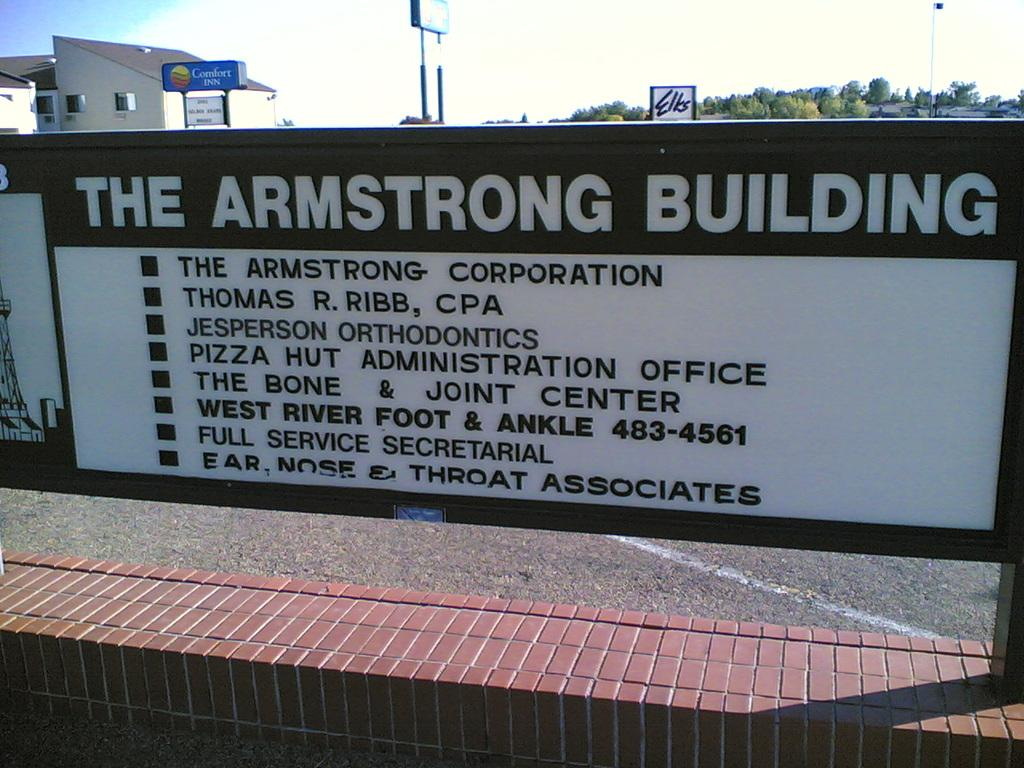<image>
Present a compact description of the photo's key features. A sign that says The Armstrong Building is on a brick wall. 